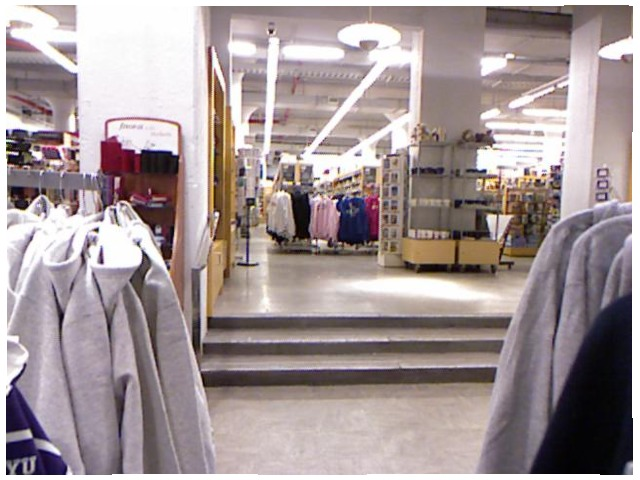<image>
Is there a hanger on the sweatshirt? Yes. Looking at the image, I can see the hanger is positioned on top of the sweatshirt, with the sweatshirt providing support. Is there a step on the floor? Yes. Looking at the image, I can see the step is positioned on top of the floor, with the floor providing support. Is there a shirt on the floor? No. The shirt is not positioned on the floor. They may be near each other, but the shirt is not supported by or resting on top of the floor. 